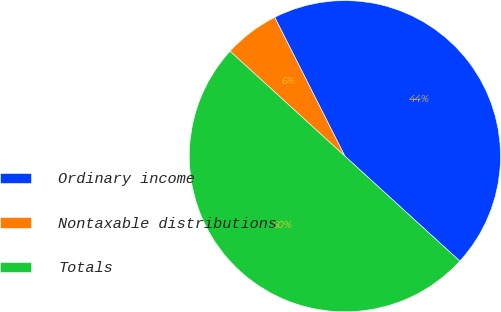Convert chart to OTSL. <chart><loc_0><loc_0><loc_500><loc_500><pie_chart><fcel>Ordinary income<fcel>Nontaxable distributions<fcel>Totals<nl><fcel>44.23%<fcel>5.77%<fcel>50.0%<nl></chart> 